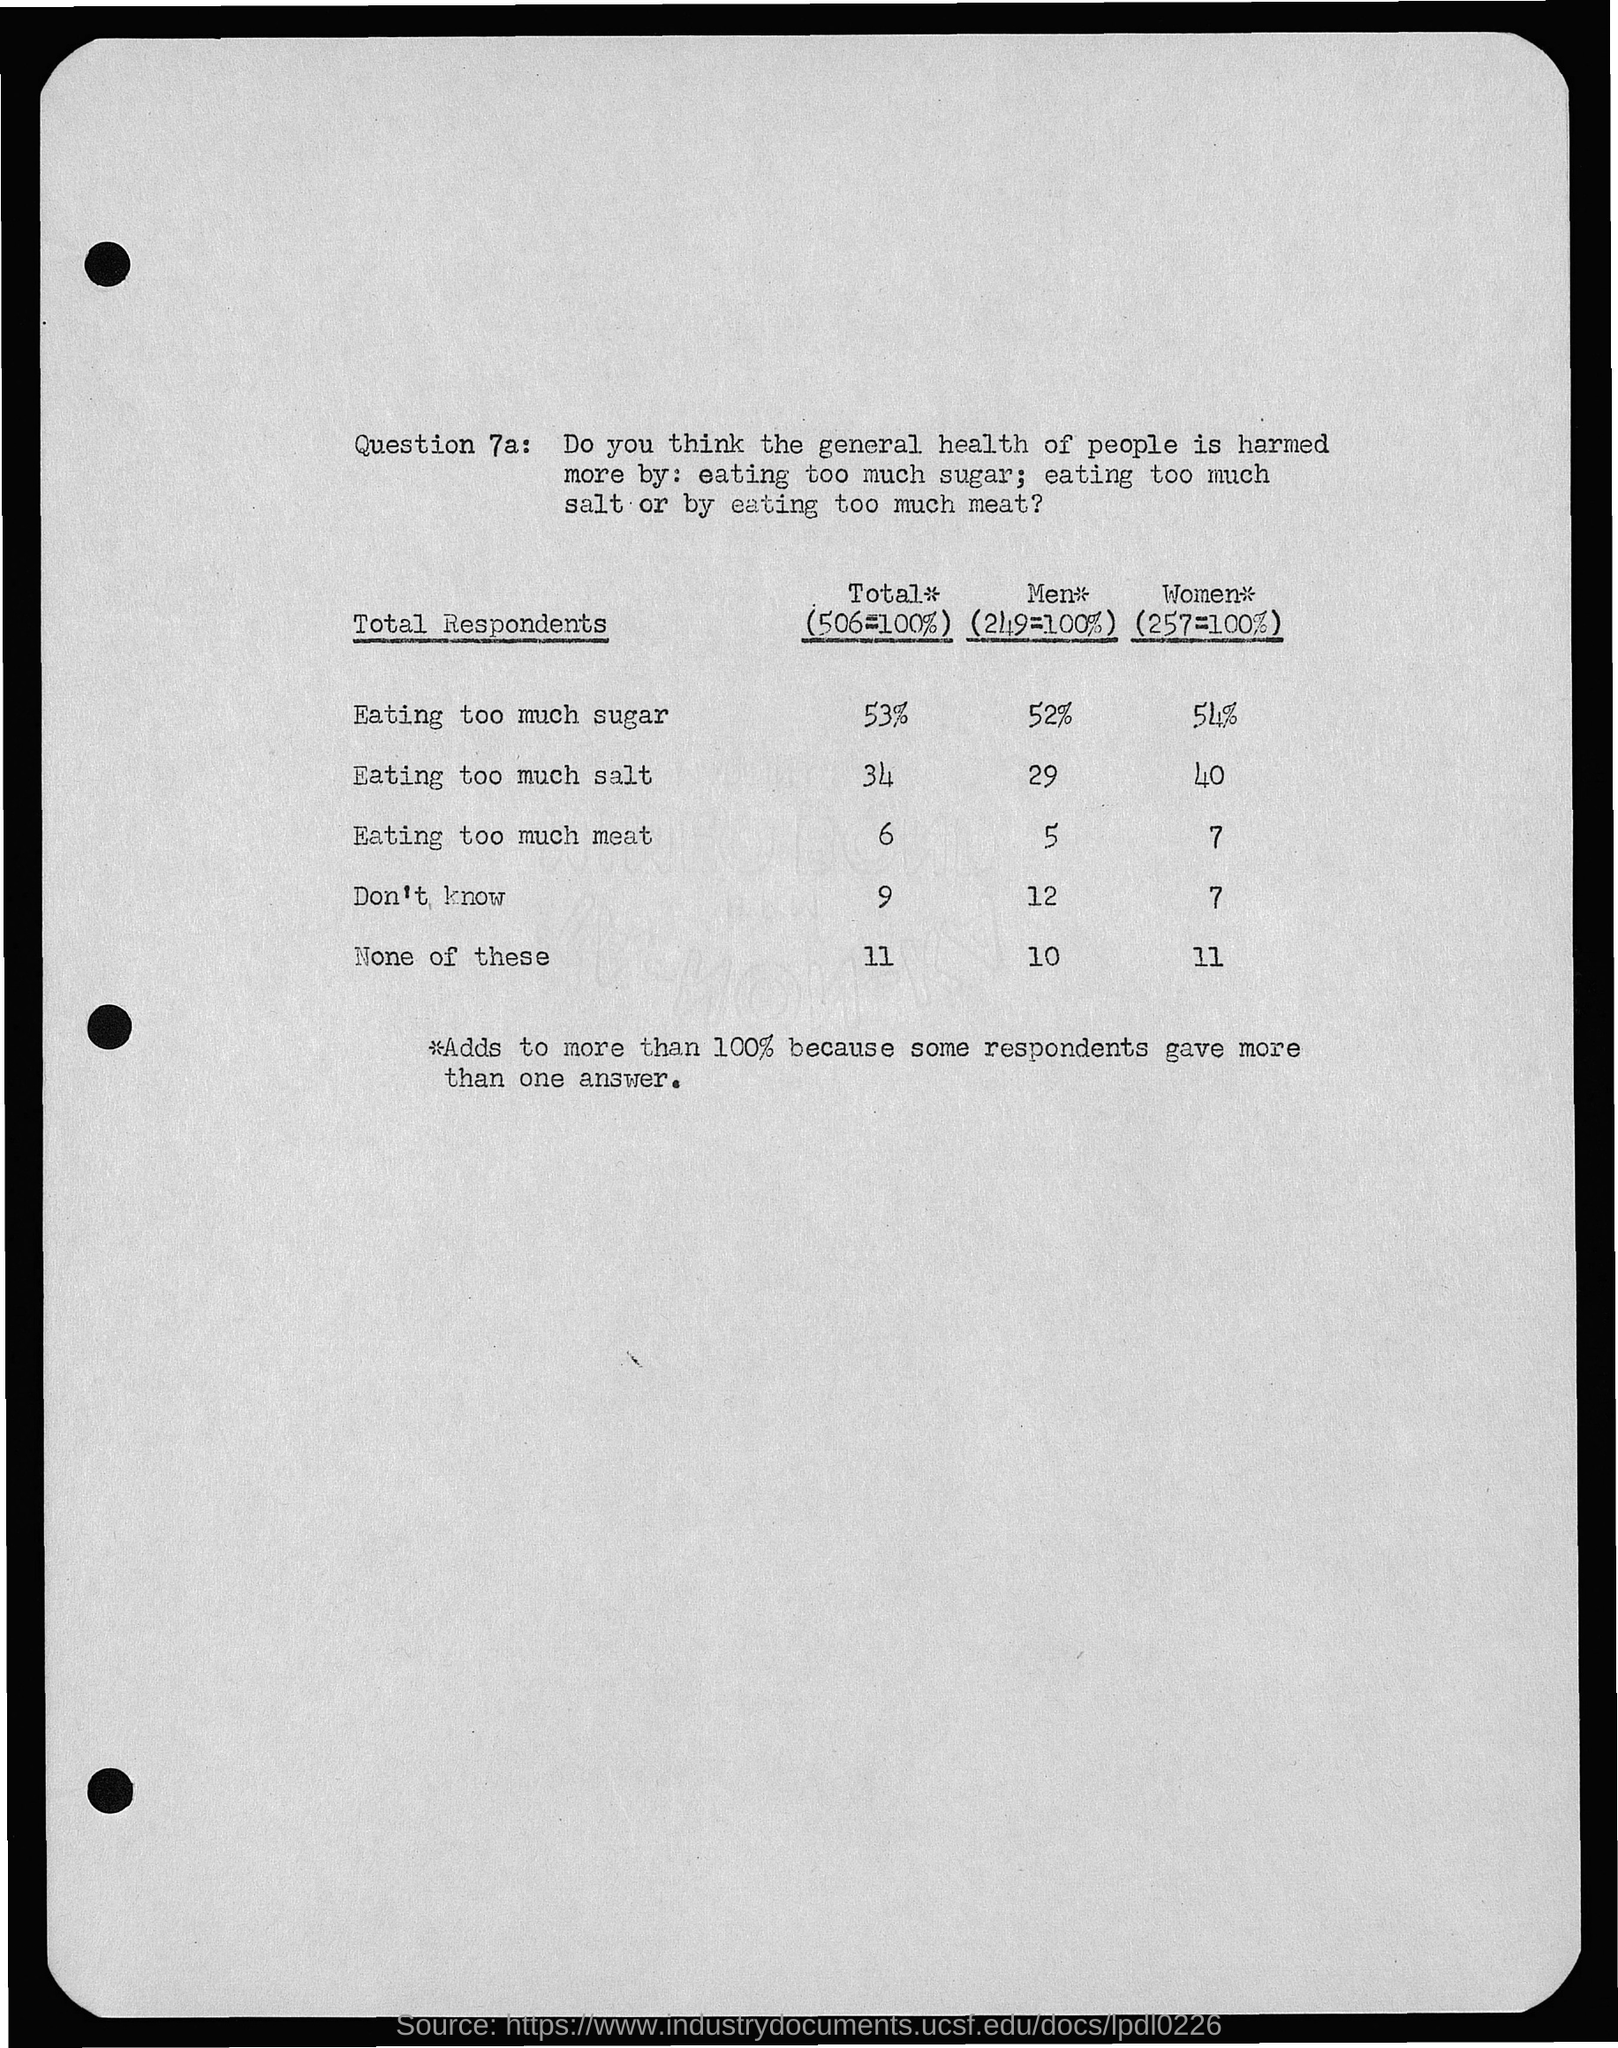What is the Question No.?
Your response must be concise. 7a. What is the total percentage of eating too much sugar?
Offer a terse response. 53%. What is the total percentage of eating too much salt?
Your response must be concise. 34. What is the total percentage of eating too much meat?
Make the answer very short. 6. What is the percentage of eating too much sugar in men?
Your answer should be compact. 52%. What is the percentage of eating too much sugar in women?
Ensure brevity in your answer.  54%. What is the percentage of eating too much salt in men?
Provide a succinct answer. 29. What is the percentage of eating too much salt in women?
Provide a short and direct response. 40. 